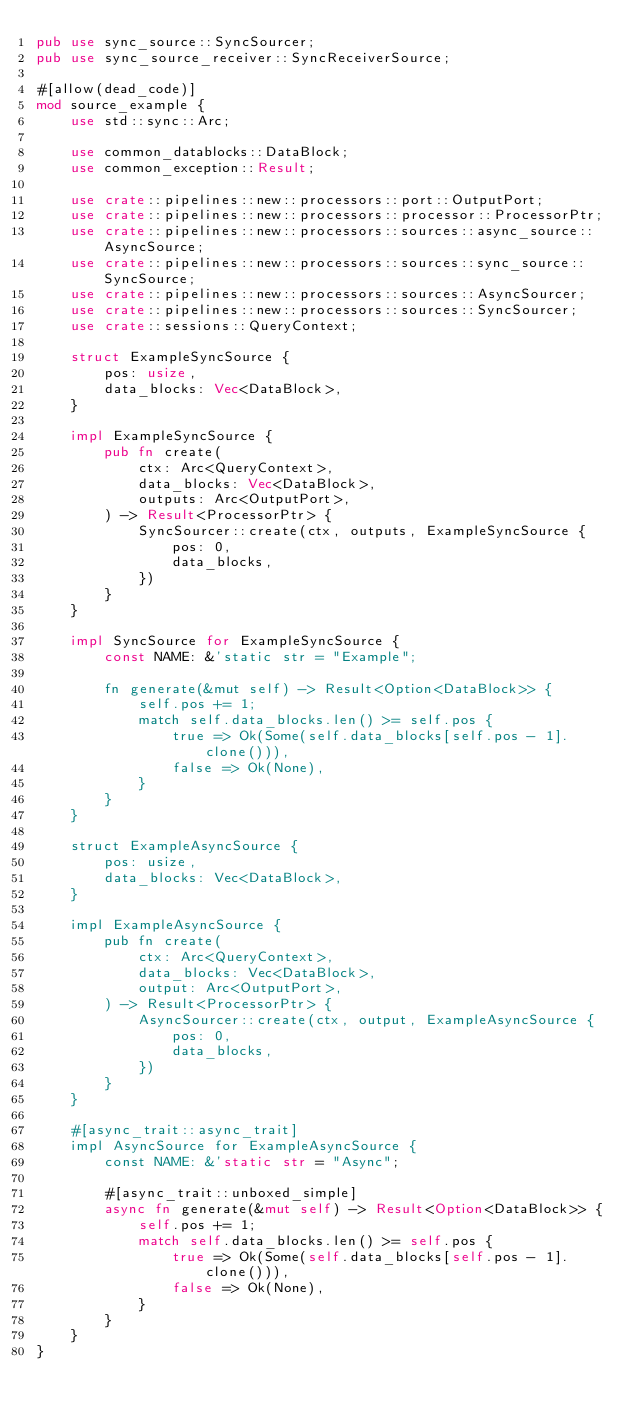Convert code to text. <code><loc_0><loc_0><loc_500><loc_500><_Rust_>pub use sync_source::SyncSourcer;
pub use sync_source_receiver::SyncReceiverSource;

#[allow(dead_code)]
mod source_example {
    use std::sync::Arc;

    use common_datablocks::DataBlock;
    use common_exception::Result;

    use crate::pipelines::new::processors::port::OutputPort;
    use crate::pipelines::new::processors::processor::ProcessorPtr;
    use crate::pipelines::new::processors::sources::async_source::AsyncSource;
    use crate::pipelines::new::processors::sources::sync_source::SyncSource;
    use crate::pipelines::new::processors::sources::AsyncSourcer;
    use crate::pipelines::new::processors::sources::SyncSourcer;
    use crate::sessions::QueryContext;

    struct ExampleSyncSource {
        pos: usize,
        data_blocks: Vec<DataBlock>,
    }

    impl ExampleSyncSource {
        pub fn create(
            ctx: Arc<QueryContext>,
            data_blocks: Vec<DataBlock>,
            outputs: Arc<OutputPort>,
        ) -> Result<ProcessorPtr> {
            SyncSourcer::create(ctx, outputs, ExampleSyncSource {
                pos: 0,
                data_blocks,
            })
        }
    }

    impl SyncSource for ExampleSyncSource {
        const NAME: &'static str = "Example";

        fn generate(&mut self) -> Result<Option<DataBlock>> {
            self.pos += 1;
            match self.data_blocks.len() >= self.pos {
                true => Ok(Some(self.data_blocks[self.pos - 1].clone())),
                false => Ok(None),
            }
        }
    }

    struct ExampleAsyncSource {
        pos: usize,
        data_blocks: Vec<DataBlock>,
    }

    impl ExampleAsyncSource {
        pub fn create(
            ctx: Arc<QueryContext>,
            data_blocks: Vec<DataBlock>,
            output: Arc<OutputPort>,
        ) -> Result<ProcessorPtr> {
            AsyncSourcer::create(ctx, output, ExampleAsyncSource {
                pos: 0,
                data_blocks,
            })
        }
    }

    #[async_trait::async_trait]
    impl AsyncSource for ExampleAsyncSource {
        const NAME: &'static str = "Async";

        #[async_trait::unboxed_simple]
        async fn generate(&mut self) -> Result<Option<DataBlock>> {
            self.pos += 1;
            match self.data_blocks.len() >= self.pos {
                true => Ok(Some(self.data_blocks[self.pos - 1].clone())),
                false => Ok(None),
            }
        }
    }
}
</code> 